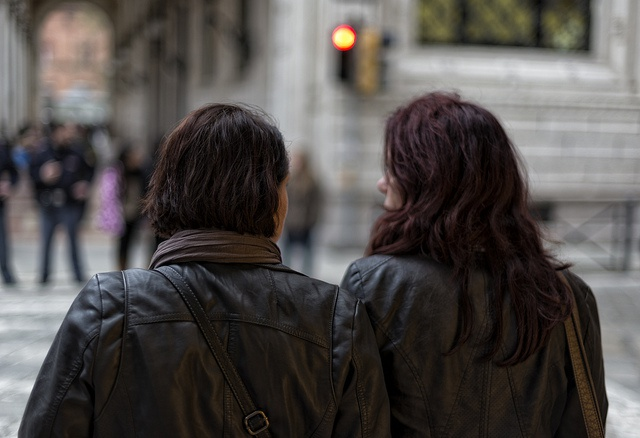Describe the objects in this image and their specific colors. I can see people in gray and black tones, people in gray, black, and darkgray tones, people in gray and black tones, handbag in gray, black, and maroon tones, and people in gray and black tones in this image. 